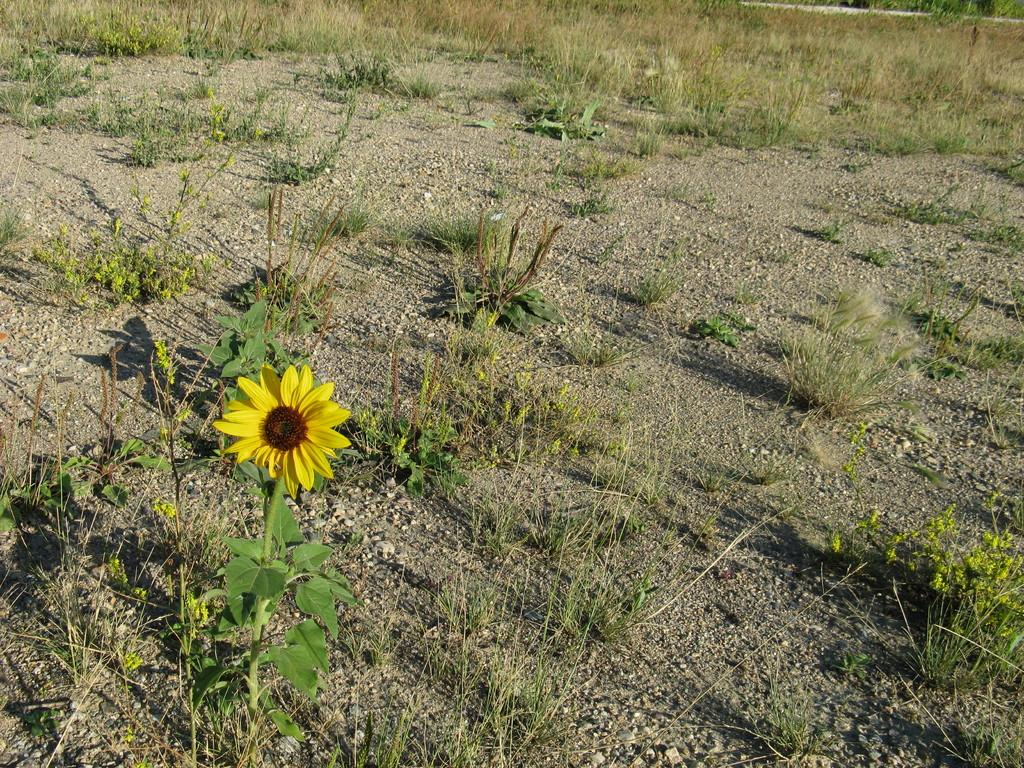What type of plant can be seen in the image? There is a plant with a sunflower in the image. What type of vegetation is visible in the image besides the sunflower? There is grass visible in the image. What can be found on the ground in the image? There are stones on the ground in the image. What type of silk is being used to support the sunflower in the image? There is no silk present in the image; the sunflower is supported by the plant itself. 